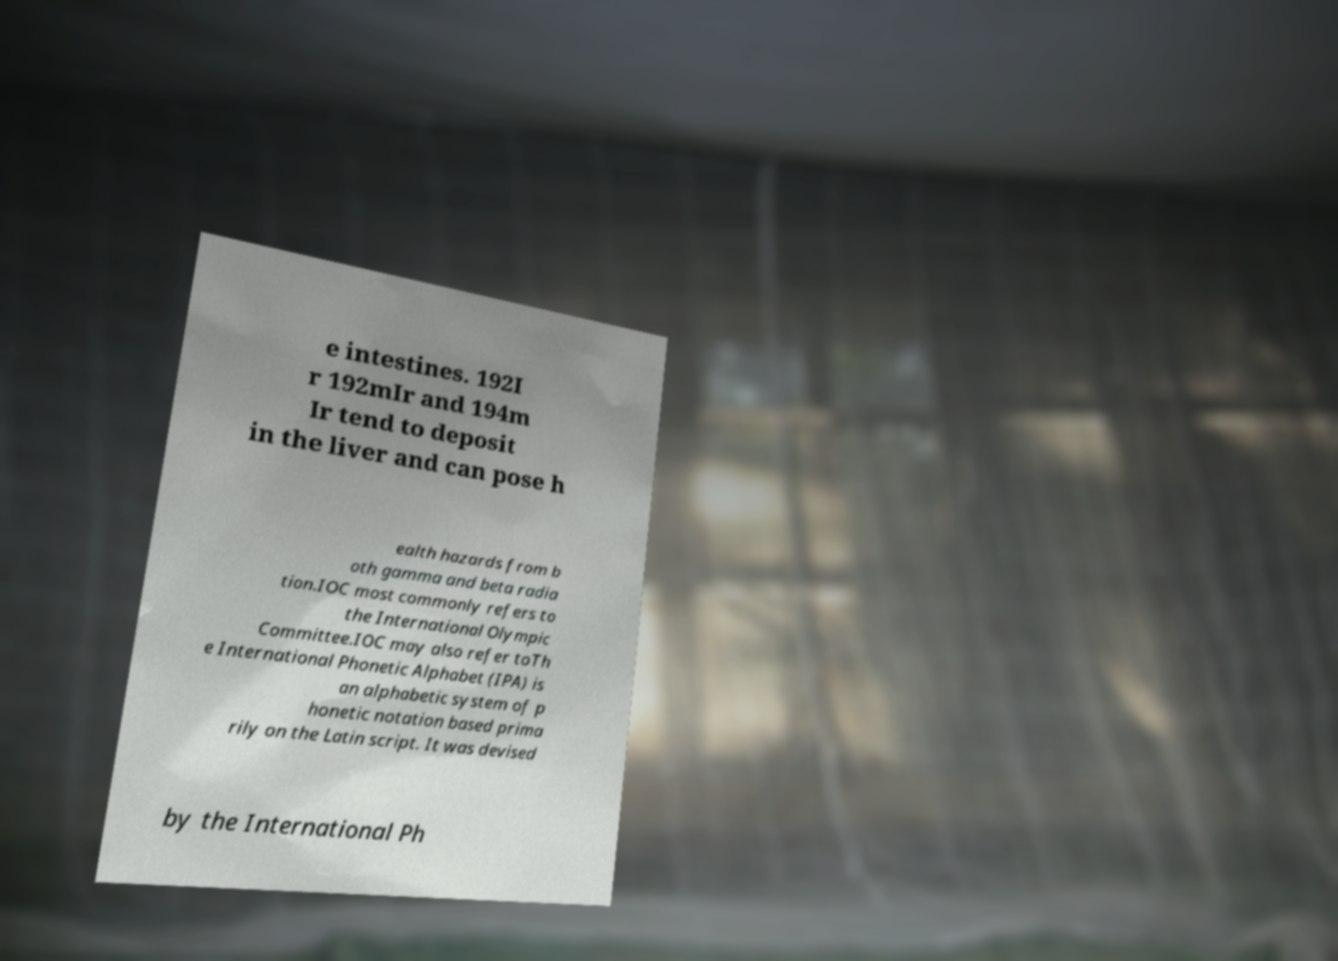For documentation purposes, I need the text within this image transcribed. Could you provide that? e intestines. 192I r 192mIr and 194m Ir tend to deposit in the liver and can pose h ealth hazards from b oth gamma and beta radia tion.IOC most commonly refers to the International Olympic Committee.IOC may also refer toTh e International Phonetic Alphabet (IPA) is an alphabetic system of p honetic notation based prima rily on the Latin script. It was devised by the International Ph 